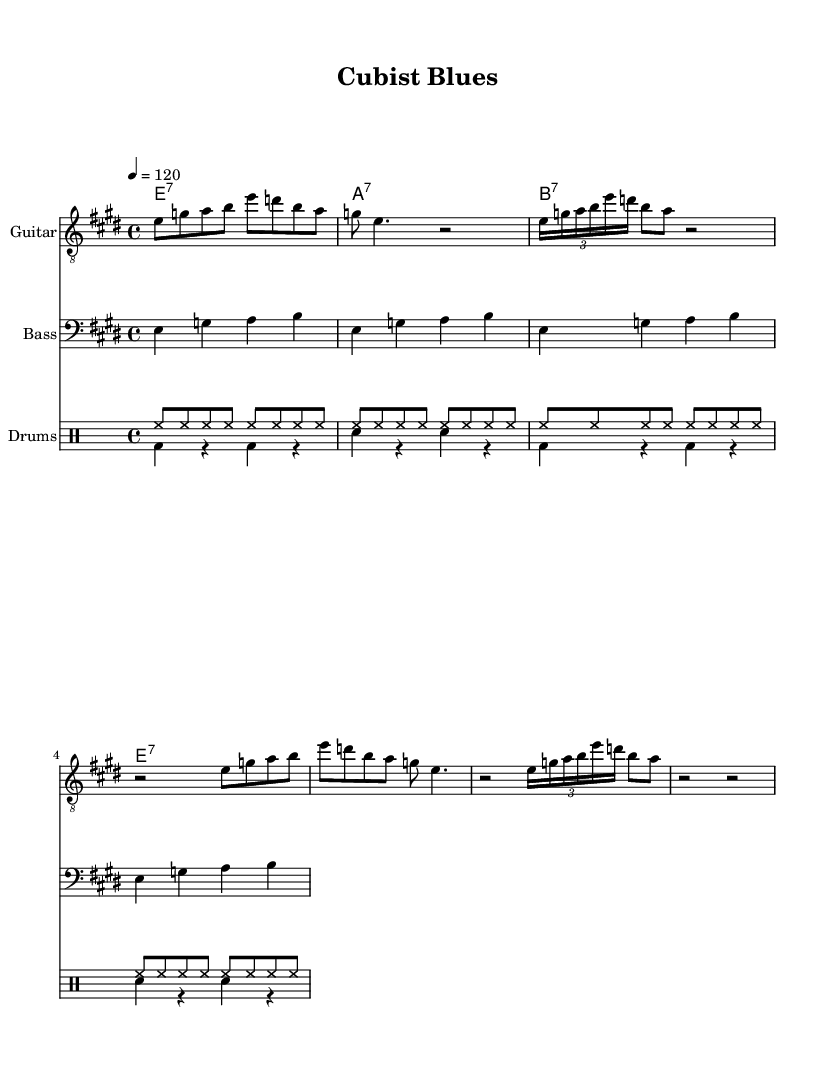What is the key signature of this music? The key signature indicates E major, which has four sharps: F#, C#, G#, and D#.
Answer: E major What is the time signature of this composition? The time signature is 4/4, as indicated at the beginning of the score.
Answer: 4/4 What is the tempo marking for this piece? The tempo marking indicates a speed of 120 beats per minute, shown as "4 = 120".
Answer: 120 How many measures are in the guitar part? The guitar part has eight measures, as seen in the repeated sections.
Answer: Eight measures What type of guitar chords are used throughout this piece? The chords in the piece are seventh chords: E7, A7, B7, and E7 again, as indicated in the chord names section.
Answer: Seventh chords What is the rhythmic feel of the drum part? The drum part features a steady eighth-note pattern for the hi-hat and alternating bass and snare patterns, typical of a blues rhythm.
Answer: Steady eighth notes What is the significance of the tuplet in the guitar riff? The tuplet indicates a triplet feel, compressing three notes into the duration usually occupied by two, which adds a syncopated, bluesy flavor to the riff.
Answer: A triplet 